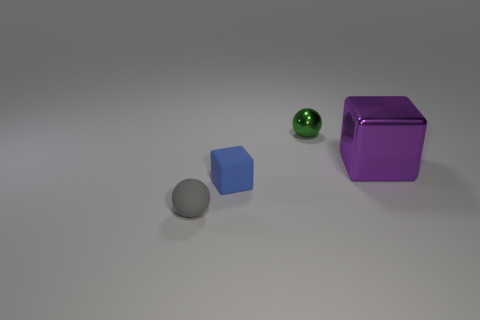Add 1 matte objects. How many objects exist? 5 Subtract all green metallic balls. Subtract all tiny rubber objects. How many objects are left? 1 Add 4 purple shiny blocks. How many purple shiny blocks are left? 5 Add 3 small blue rubber objects. How many small blue rubber objects exist? 4 Subtract 0 purple cylinders. How many objects are left? 4 